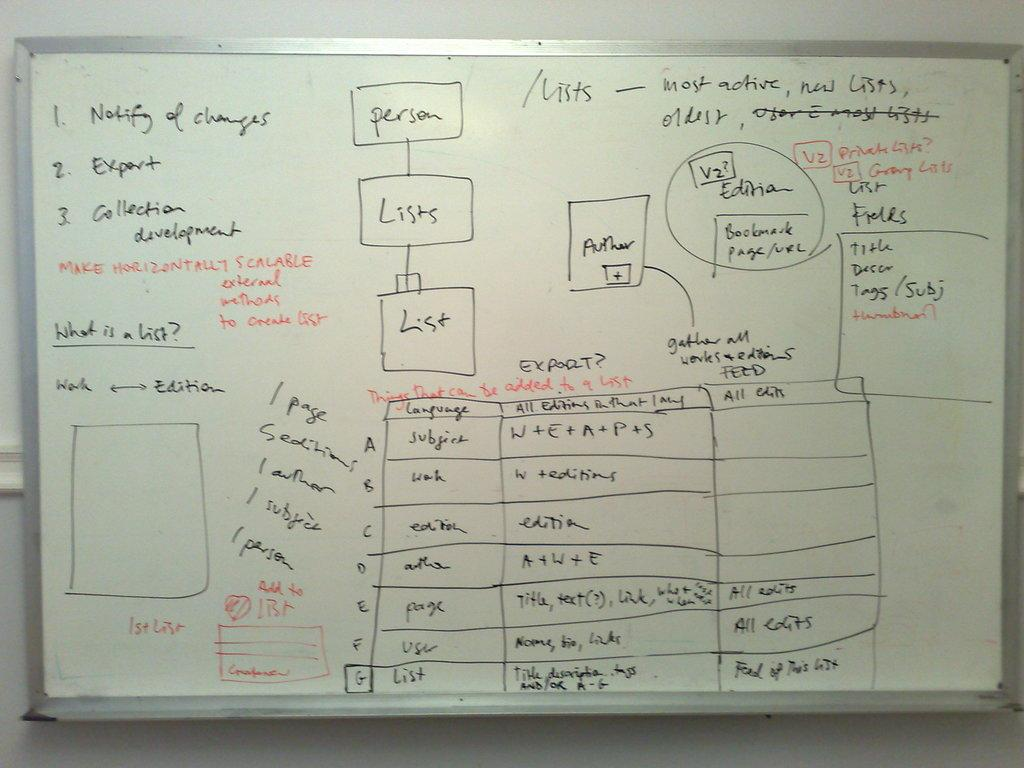<image>
Render a clear and concise summary of the photo. The first item in a list on a white board is to notify of changes. 